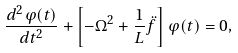Convert formula to latex. <formula><loc_0><loc_0><loc_500><loc_500>\frac { d ^ { 2 } \varphi ( t ) } { d t ^ { 2 } } + \left [ - \Omega ^ { 2 } + \frac { 1 } { L } \ddot { f } \right ] \varphi ( t ) = 0 ,</formula> 